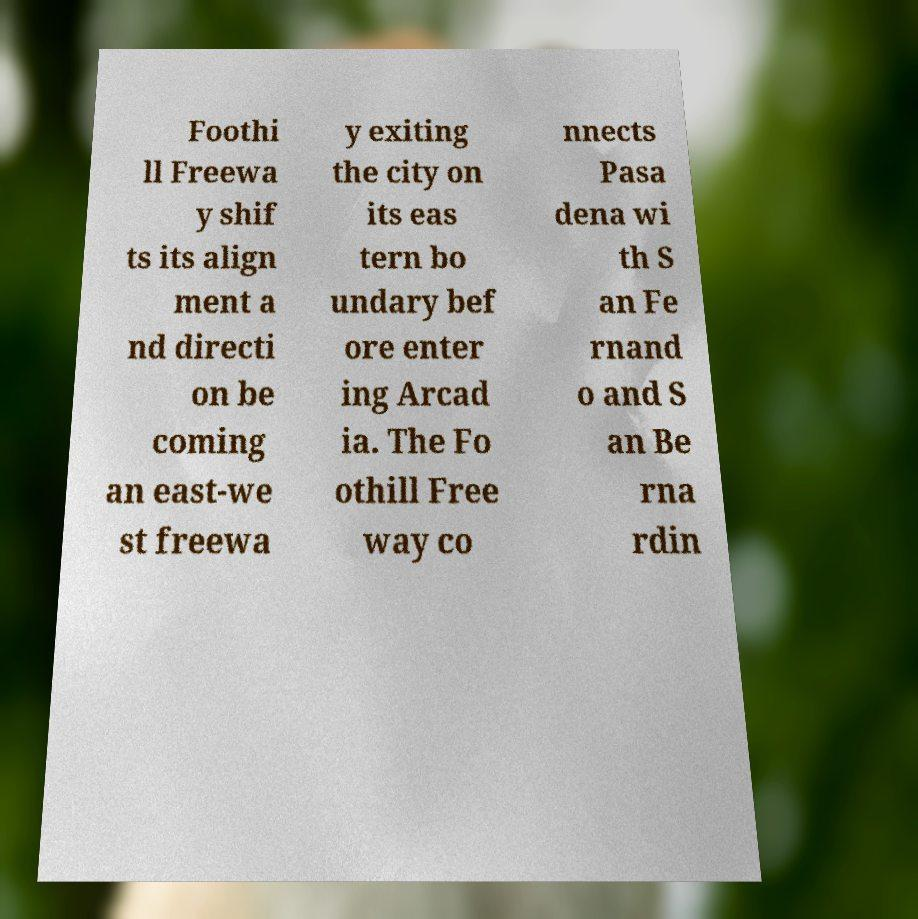Can you accurately transcribe the text from the provided image for me? Foothi ll Freewa y shif ts its align ment a nd directi on be coming an east-we st freewa y exiting the city on its eas tern bo undary bef ore enter ing Arcad ia. The Fo othill Free way co nnects Pasa dena wi th S an Fe rnand o and S an Be rna rdin 